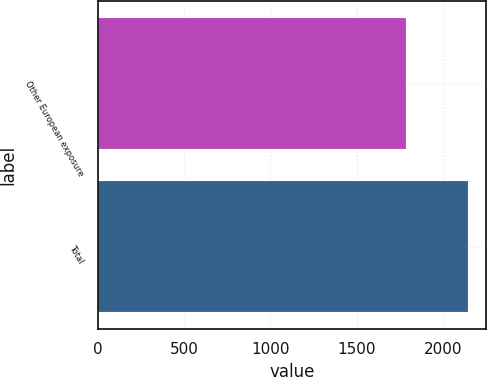<chart> <loc_0><loc_0><loc_500><loc_500><bar_chart><fcel>Other European exposure<fcel>Total<nl><fcel>1788<fcel>2146<nl></chart> 